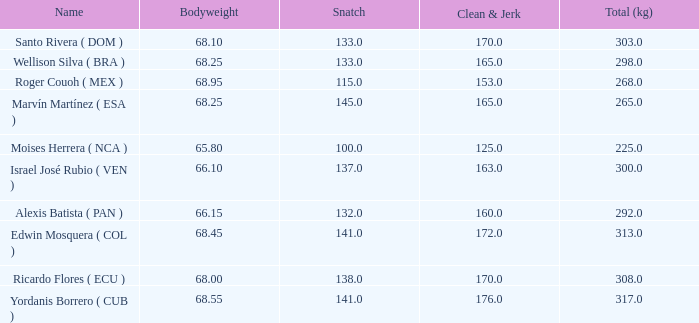Which Total (kg) has a Clean & Jerk smaller than 153, and a Snatch smaller than 100? None. 